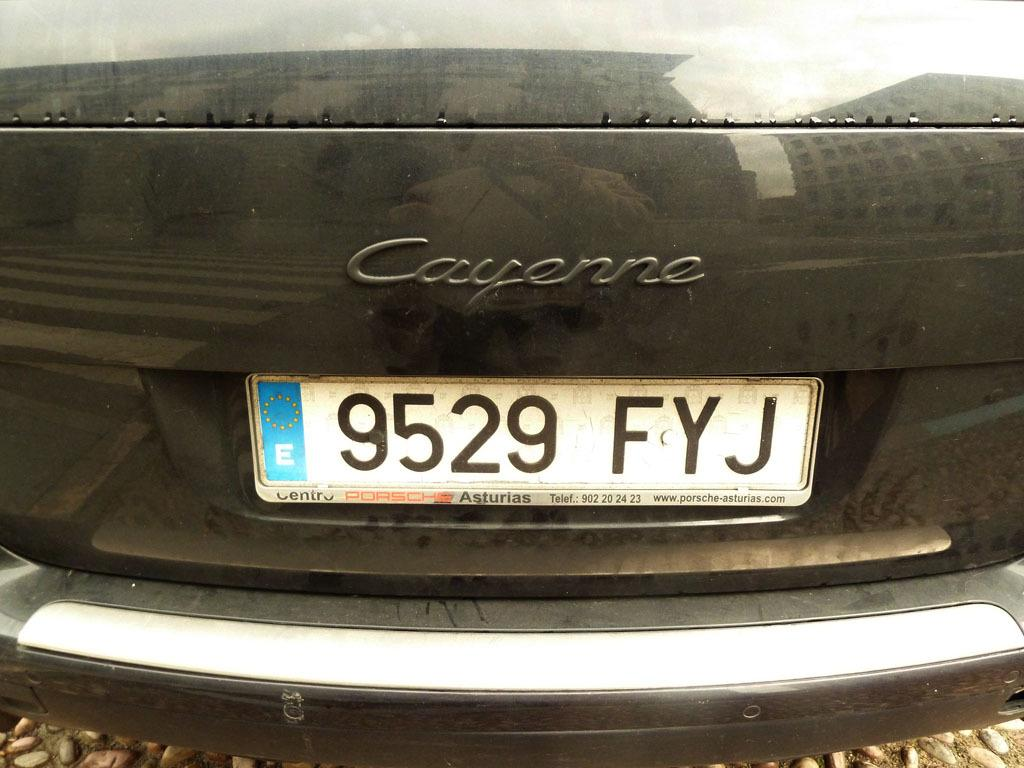<image>
Create a compact narrative representing the image presented. A black Cayenne has dust all over the license plate. 